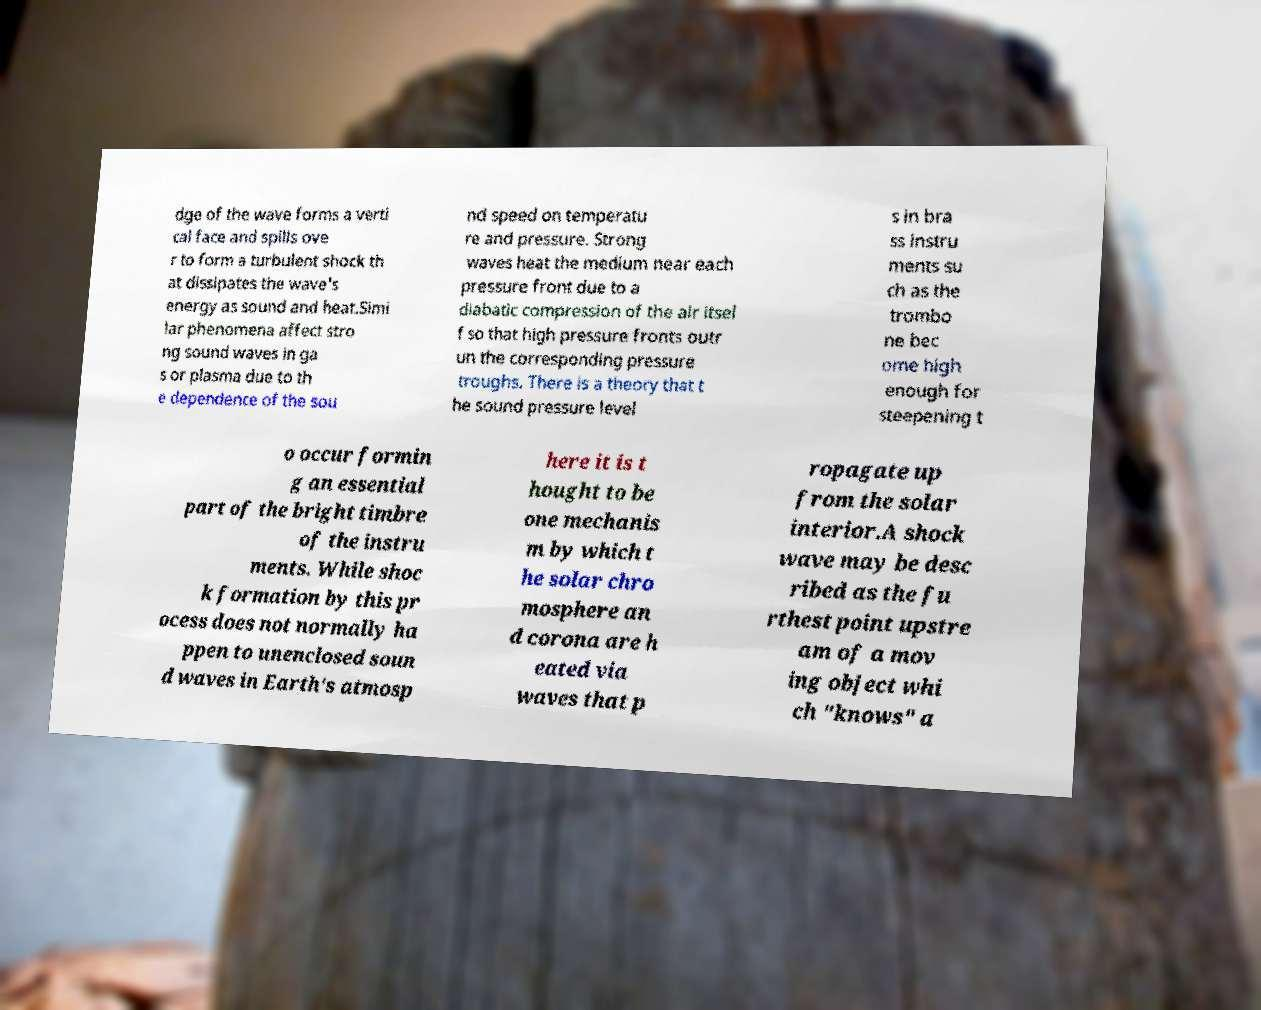Could you assist in decoding the text presented in this image and type it out clearly? dge of the wave forms a verti cal face and spills ove r to form a turbulent shock th at dissipates the wave's energy as sound and heat.Simi lar phenomena affect stro ng sound waves in ga s or plasma due to th e dependence of the sou nd speed on temperatu re and pressure. Strong waves heat the medium near each pressure front due to a diabatic compression of the air itsel f so that high pressure fronts outr un the corresponding pressure troughs. There is a theory that t he sound pressure level s in bra ss instru ments su ch as the trombo ne bec ome high enough for steepening t o occur formin g an essential part of the bright timbre of the instru ments. While shoc k formation by this pr ocess does not normally ha ppen to unenclosed soun d waves in Earth's atmosp here it is t hought to be one mechanis m by which t he solar chro mosphere an d corona are h eated via waves that p ropagate up from the solar interior.A shock wave may be desc ribed as the fu rthest point upstre am of a mov ing object whi ch "knows" a 